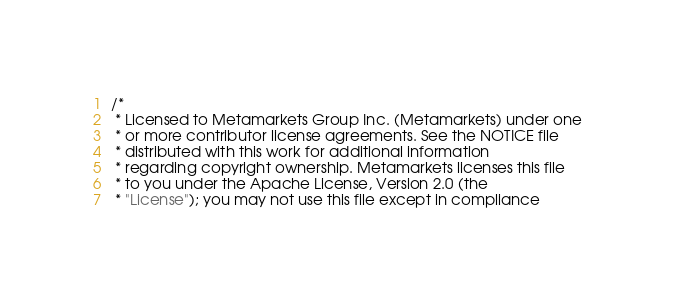Convert code to text. <code><loc_0><loc_0><loc_500><loc_500><_Java_>/*
 * Licensed to Metamarkets Group Inc. (Metamarkets) under one
 * or more contributor license agreements. See the NOTICE file
 * distributed with this work for additional information
 * regarding copyright ownership. Metamarkets licenses this file
 * to you under the Apache License, Version 2.0 (the
 * "License"); you may not use this file except in compliance</code> 